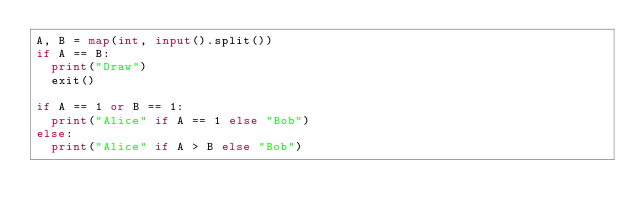<code> <loc_0><loc_0><loc_500><loc_500><_Python_>A, B = map(int, input().split())
if A == B:
  print("Draw")
  exit()

if A == 1 or B == 1:
  print("Alice" if A == 1 else "Bob")
else:
  print("Alice" if A > B else "Bob")</code> 